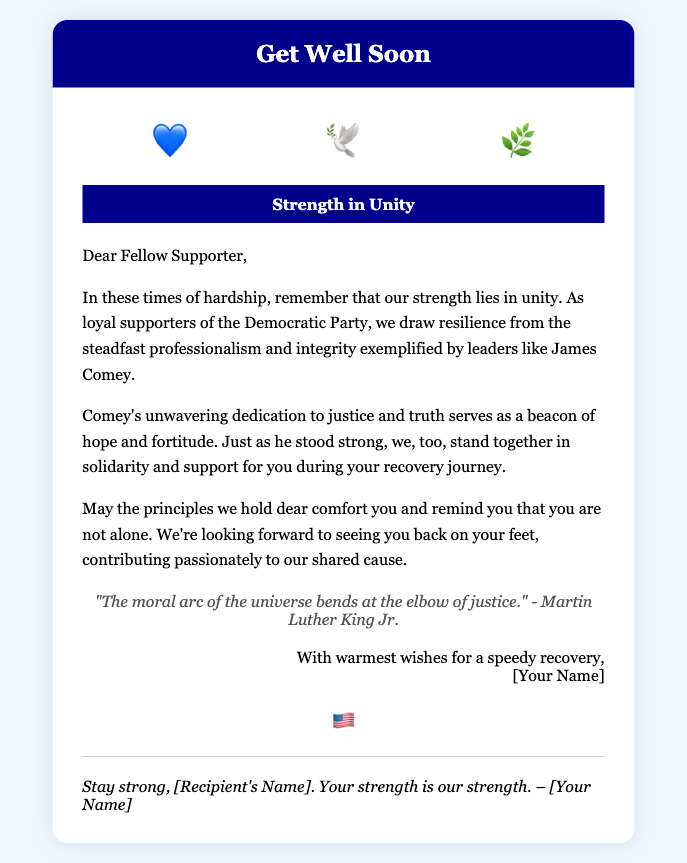what is the title of the card? The title is prominently displayed in the card header, which identifies the purpose of the card.
Answer: Get Well Soon who is the card addressed to? The card is personally addressed to a fellow supporter, as indicated in the message section.
Answer: Fellow Supporter what symbols are displayed on the card? The symbols represent unity and resilience, and are visually presented in a specific area of the card.
Answer: 💙 🕊️ 🌿 who is quoted in the card? The quote included in the card mentions a notable figure known for their stance on justice.
Answer: Martin Luther King Jr what does the banner message read? The banner highlights a theme that resonates with the overall message of the card.
Answer: Strength in Unity who is the author of the card? The closing of the card includes a placeholder for the name of the person sending the wishes.
Answer: [Your Name] what is the color of the card's header? The header's color is specifically designed to create a calming and sturdy appearance.
Answer: #00008B what is the theme emphasized in the card? The overall message encourages a specific sentiment related to the Democratic Party's values in times of hardship.
Answer: Unity and Resilience 